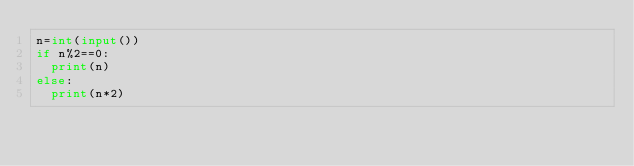<code> <loc_0><loc_0><loc_500><loc_500><_Python_>n=int(input())
if n%2==0:
  print(n)
else:
  print(n*2)</code> 